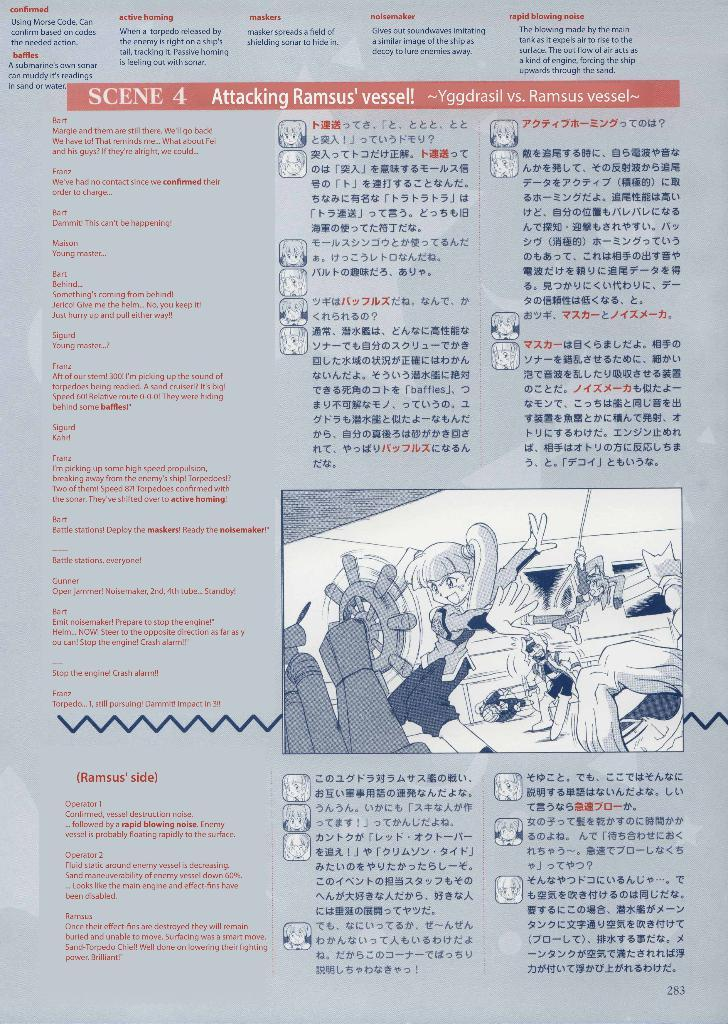<image>
Render a clear and concise summary of the photo. A write out of Scene 4 of an anime has an illustration of a girl trying to steer a ship. 